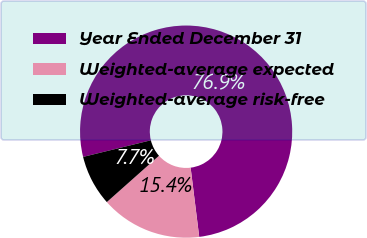Convert chart to OTSL. <chart><loc_0><loc_0><loc_500><loc_500><pie_chart><fcel>Year Ended December 31<fcel>Weighted-average expected<fcel>Weighted-average risk-free<nl><fcel>76.87%<fcel>15.41%<fcel>7.73%<nl></chart> 